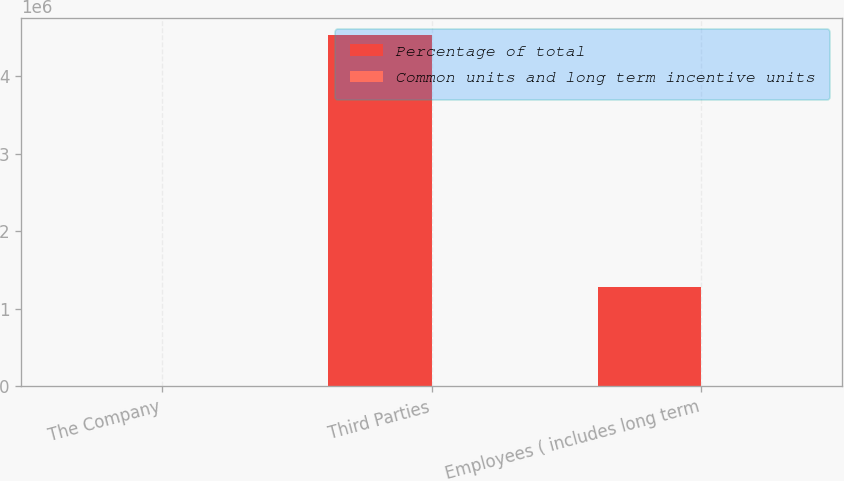Convert chart to OTSL. <chart><loc_0><loc_0><loc_500><loc_500><stacked_bar_chart><ecel><fcel>The Company<fcel>Third Parties<fcel>Employees ( includes long term<nl><fcel>Percentage of total<fcel>92.6<fcel>4.53055e+06<fcel>1.28858e+06<nl><fcel>Common units and long term incentive units<fcel>92.6<fcel>5.7<fcel>1.7<nl></chart> 